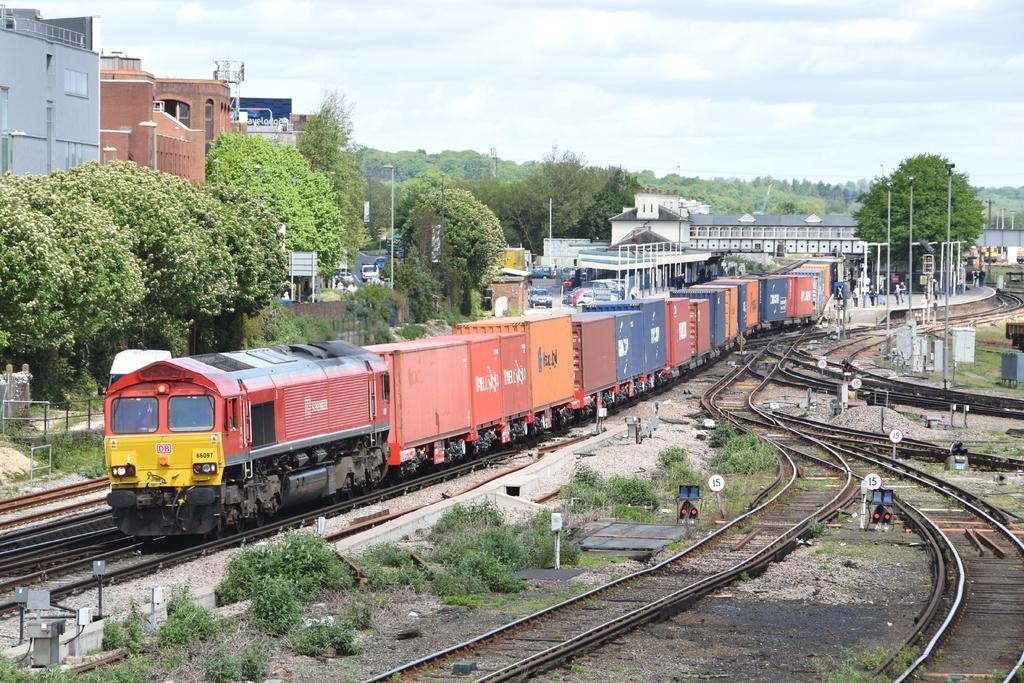What is the main subject of the image? The main subject of the image is a train. Where is the train located in the image? The train is on a railway track. What can be seen in the background of the image? In the background of the image, there are trees, the sky, plants, poles, and other objects. What is the purpose of the lake in the image? There is no lake present in the image; it features a train on a railway track with a background that includes trees, the sky, plants, poles, and other objects. 